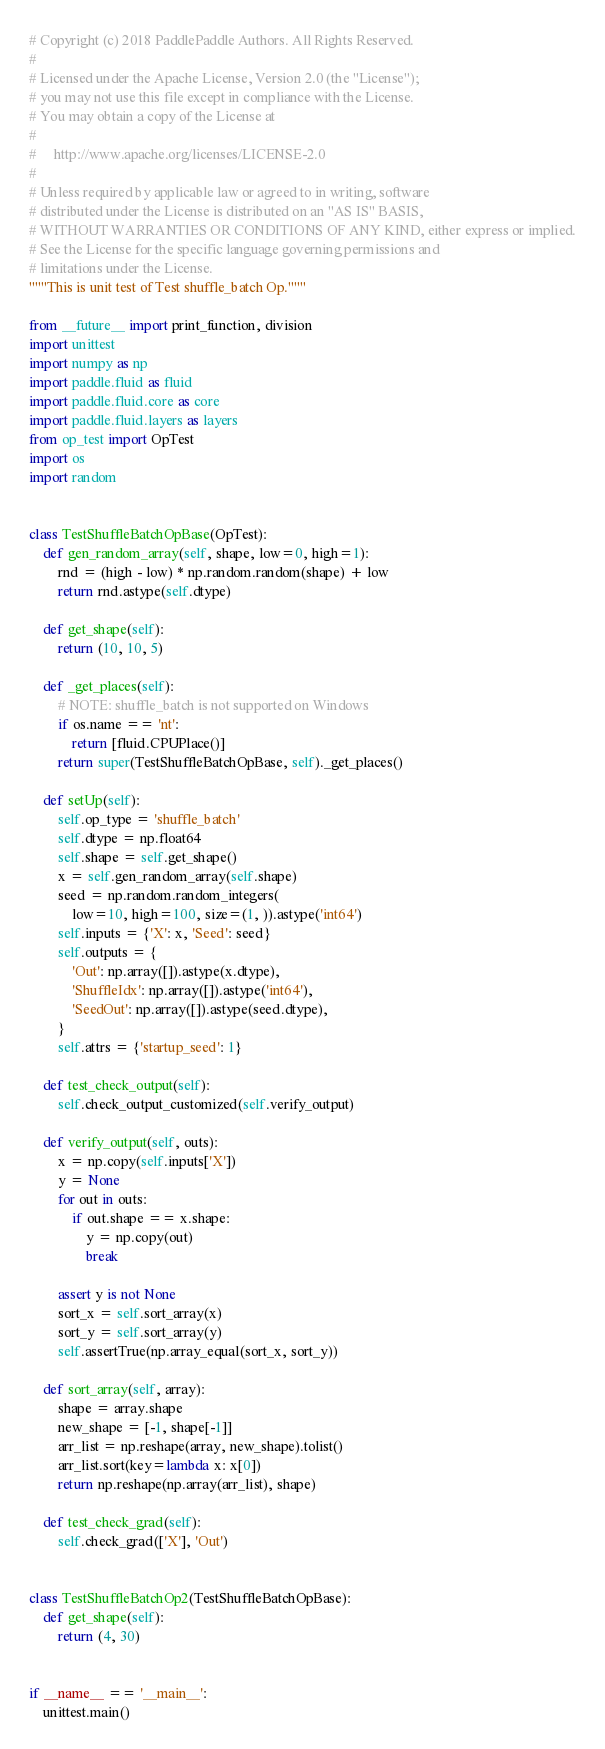Convert code to text. <code><loc_0><loc_0><loc_500><loc_500><_Python_># Copyright (c) 2018 PaddlePaddle Authors. All Rights Reserved.
#
# Licensed under the Apache License, Version 2.0 (the "License");
# you may not use this file except in compliance with the License.
# You may obtain a copy of the License at
#
#     http://www.apache.org/licenses/LICENSE-2.0
#
# Unless required by applicable law or agreed to in writing, software
# distributed under the License is distributed on an "AS IS" BASIS,
# WITHOUT WARRANTIES OR CONDITIONS OF ANY KIND, either express or implied.
# See the License for the specific language governing permissions and
# limitations under the License.
"""This is unit test of Test shuffle_batch Op."""

from __future__ import print_function, division
import unittest
import numpy as np
import paddle.fluid as fluid
import paddle.fluid.core as core
import paddle.fluid.layers as layers
from op_test import OpTest
import os
import random


class TestShuffleBatchOpBase(OpTest):
    def gen_random_array(self, shape, low=0, high=1):
        rnd = (high - low) * np.random.random(shape) + low
        return rnd.astype(self.dtype)

    def get_shape(self):
        return (10, 10, 5)

    def _get_places(self):
        # NOTE: shuffle_batch is not supported on Windows
        if os.name == 'nt':
            return [fluid.CPUPlace()]
        return super(TestShuffleBatchOpBase, self)._get_places()

    def setUp(self):
        self.op_type = 'shuffle_batch'
        self.dtype = np.float64
        self.shape = self.get_shape()
        x = self.gen_random_array(self.shape)
        seed = np.random.random_integers(
            low=10, high=100, size=(1, )).astype('int64')
        self.inputs = {'X': x, 'Seed': seed}
        self.outputs = {
            'Out': np.array([]).astype(x.dtype),
            'ShuffleIdx': np.array([]).astype('int64'),
            'SeedOut': np.array([]).astype(seed.dtype),
        }
        self.attrs = {'startup_seed': 1}

    def test_check_output(self):
        self.check_output_customized(self.verify_output)

    def verify_output(self, outs):
        x = np.copy(self.inputs['X'])
        y = None
        for out in outs:
            if out.shape == x.shape:
                y = np.copy(out)
                break

        assert y is not None
        sort_x = self.sort_array(x)
        sort_y = self.sort_array(y)
        self.assertTrue(np.array_equal(sort_x, sort_y))

    def sort_array(self, array):
        shape = array.shape
        new_shape = [-1, shape[-1]]
        arr_list = np.reshape(array, new_shape).tolist()
        arr_list.sort(key=lambda x: x[0])
        return np.reshape(np.array(arr_list), shape)

    def test_check_grad(self):
        self.check_grad(['X'], 'Out')


class TestShuffleBatchOp2(TestShuffleBatchOpBase):
    def get_shape(self):
        return (4, 30)


if __name__ == '__main__':
    unittest.main()
</code> 